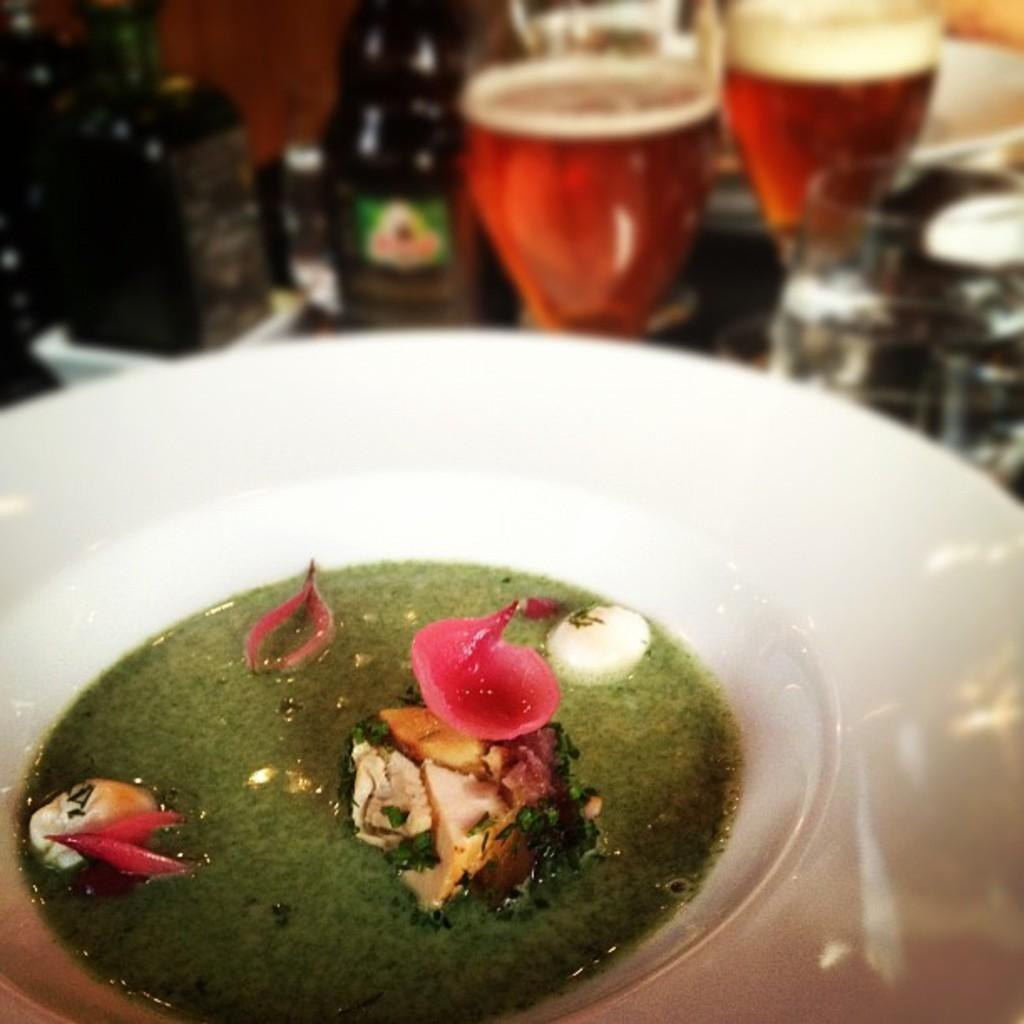What is the color of the container in the image? The container in the image is white. What else can be seen in the image besides the container? There are glasses visible in the image. Is the container made of tin in the image? There is no information about the material of the container in the image, but it is not mentioned as being made of tin. 